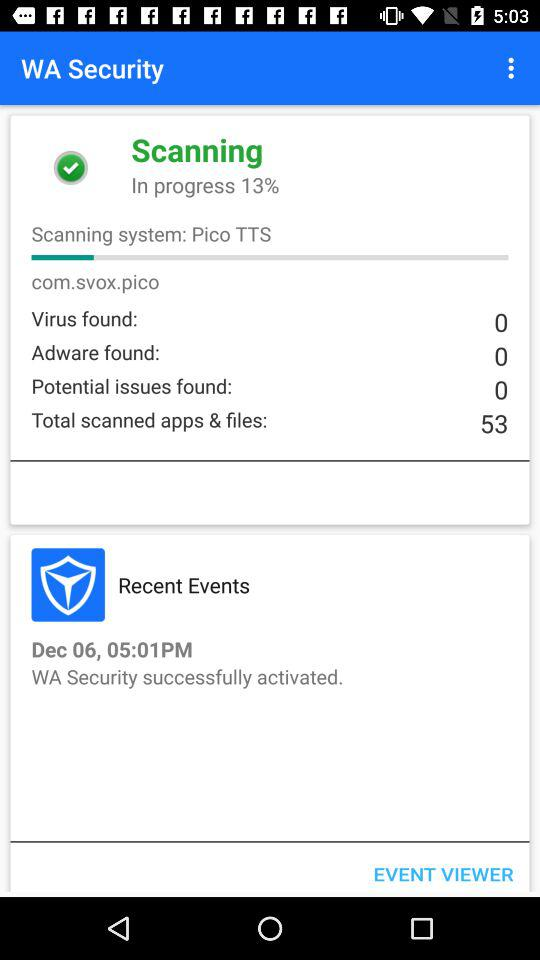How many potential issues are found? There are 0 potential issues that are found. 